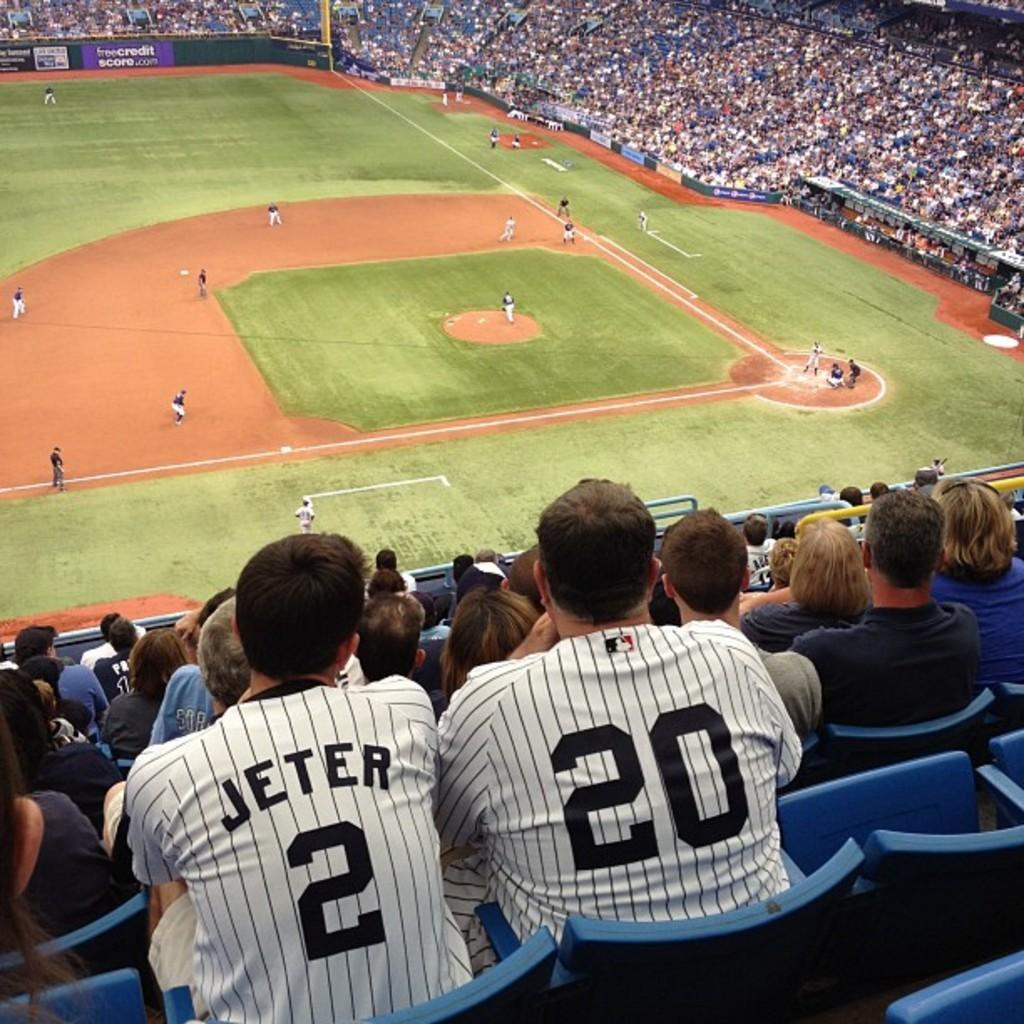<image>
Give a short and clear explanation of the subsequent image. baseball game in crwded stadium with freecreditscore.com being a sponsor 